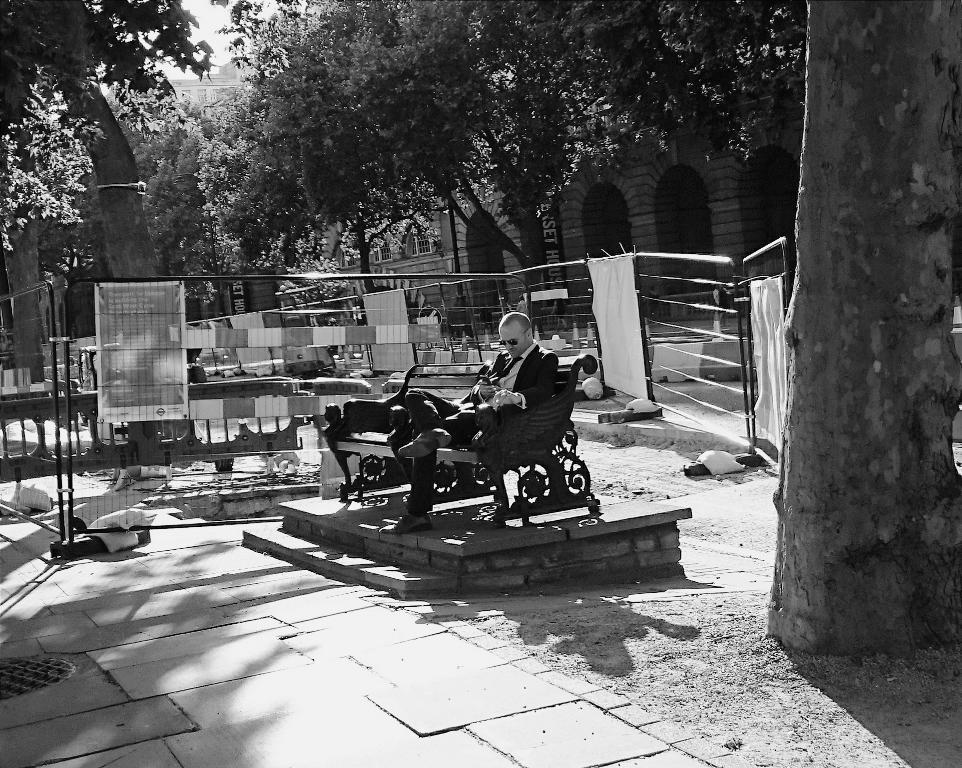What is the color scheme of the image? The image is black and white. What is the man in the image doing? The man is sitting on a bench in the image. What can be seen hanging in the image? There are banners in the image. What type of barrier is present in the image? There is a fence in the image. What type of vegetation is visible in the image? There are trees in the image. What type of structure is present in the image? There is a building in the image. What is visible in the background of the image? The sky is visible in the background of the image. What type of verse is being recited by the steam in the image? There is no steam present in the image, and therefore no verse can be recited. What type of destruction is visible in the image? There is no destruction visible in the image; it features a man sitting on a bench, banners, a fence, trees, a building, and the sky. 